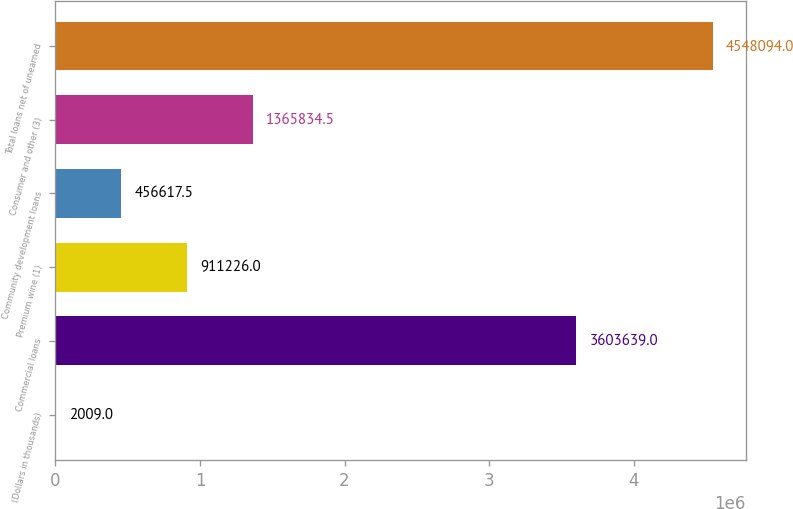Convert chart to OTSL. <chart><loc_0><loc_0><loc_500><loc_500><bar_chart><fcel>(Dollars in thousands)<fcel>Commercial loans<fcel>Premium wine (1)<fcel>Community development loans<fcel>Consumer and other (3)<fcel>Total loans net of unearned<nl><fcel>2009<fcel>3.60364e+06<fcel>911226<fcel>456618<fcel>1.36583e+06<fcel>4.54809e+06<nl></chart> 